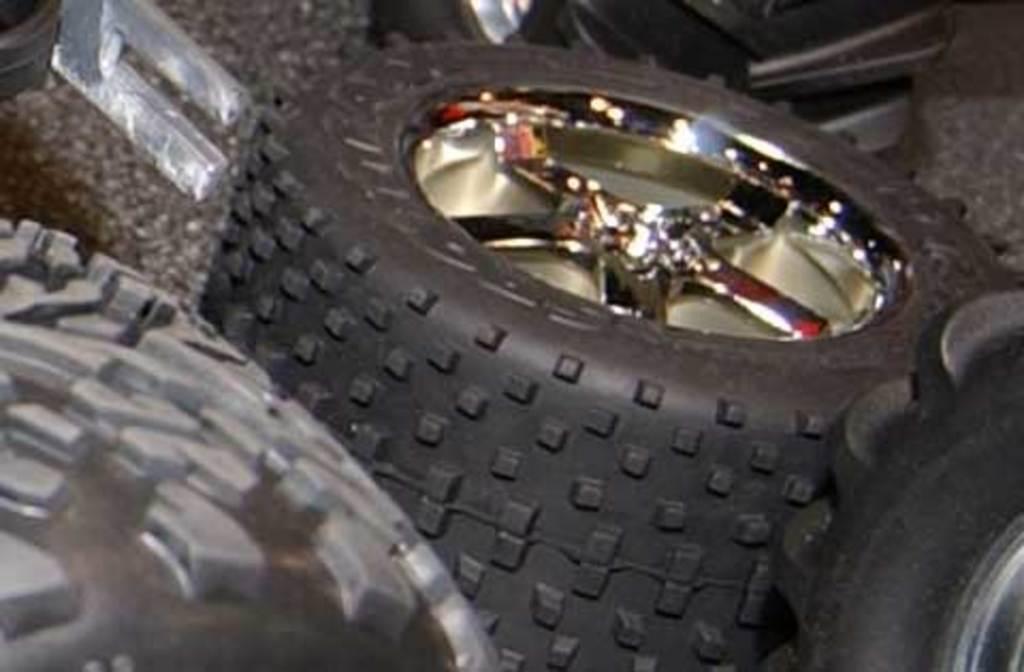In one or two sentences, can you explain what this image depicts? In this image, I can see tyres and some objects on the floor. 